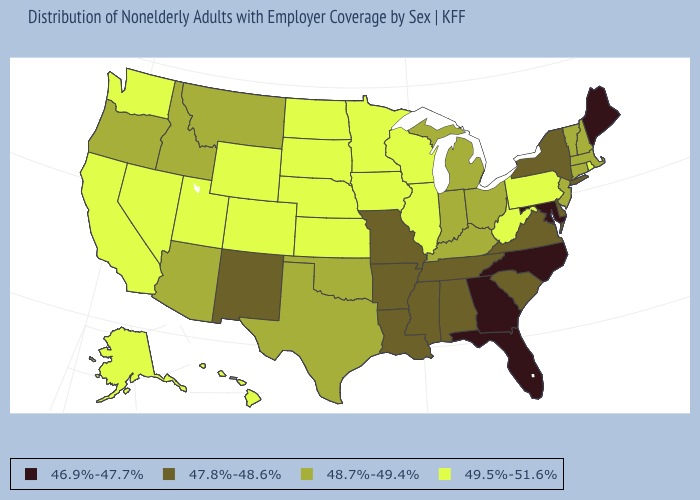What is the value of Massachusetts?
Quick response, please. 48.7%-49.4%. What is the value of Pennsylvania?
Write a very short answer. 49.5%-51.6%. What is the highest value in the South ?
Answer briefly. 49.5%-51.6%. Name the states that have a value in the range 47.8%-48.6%?
Short answer required. Alabama, Arkansas, Delaware, Louisiana, Mississippi, Missouri, New Mexico, New York, South Carolina, Tennessee, Virginia. Which states have the highest value in the USA?
Answer briefly. Alaska, California, Colorado, Hawaii, Illinois, Iowa, Kansas, Minnesota, Nebraska, Nevada, North Dakota, Pennsylvania, Rhode Island, South Dakota, Utah, Washington, West Virginia, Wisconsin, Wyoming. Which states have the lowest value in the MidWest?
Keep it brief. Missouri. Name the states that have a value in the range 48.7%-49.4%?
Write a very short answer. Arizona, Connecticut, Idaho, Indiana, Kentucky, Massachusetts, Michigan, Montana, New Hampshire, New Jersey, Ohio, Oklahoma, Oregon, Texas, Vermont. Name the states that have a value in the range 46.9%-47.7%?
Keep it brief. Florida, Georgia, Maine, Maryland, North Carolina. Does Montana have a lower value than Hawaii?
Quick response, please. Yes. Which states have the highest value in the USA?
Keep it brief. Alaska, California, Colorado, Hawaii, Illinois, Iowa, Kansas, Minnesota, Nebraska, Nevada, North Dakota, Pennsylvania, Rhode Island, South Dakota, Utah, Washington, West Virginia, Wisconsin, Wyoming. Which states have the lowest value in the USA?
Short answer required. Florida, Georgia, Maine, Maryland, North Carolina. What is the lowest value in the USA?
Write a very short answer. 46.9%-47.7%. Does the map have missing data?
Keep it brief. No. How many symbols are there in the legend?
Give a very brief answer. 4. 